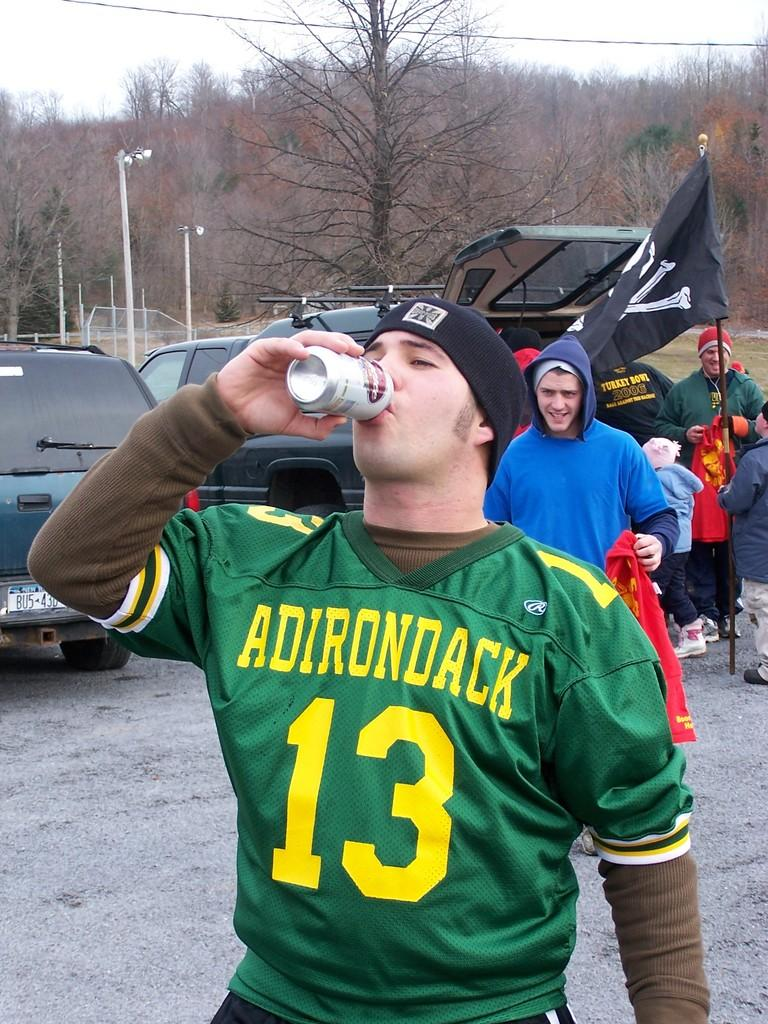<image>
Offer a succinct explanation of the picture presented. THE MAN IS WEARING A GREEN JERSEY WITH ADIRONDACK ON IT 